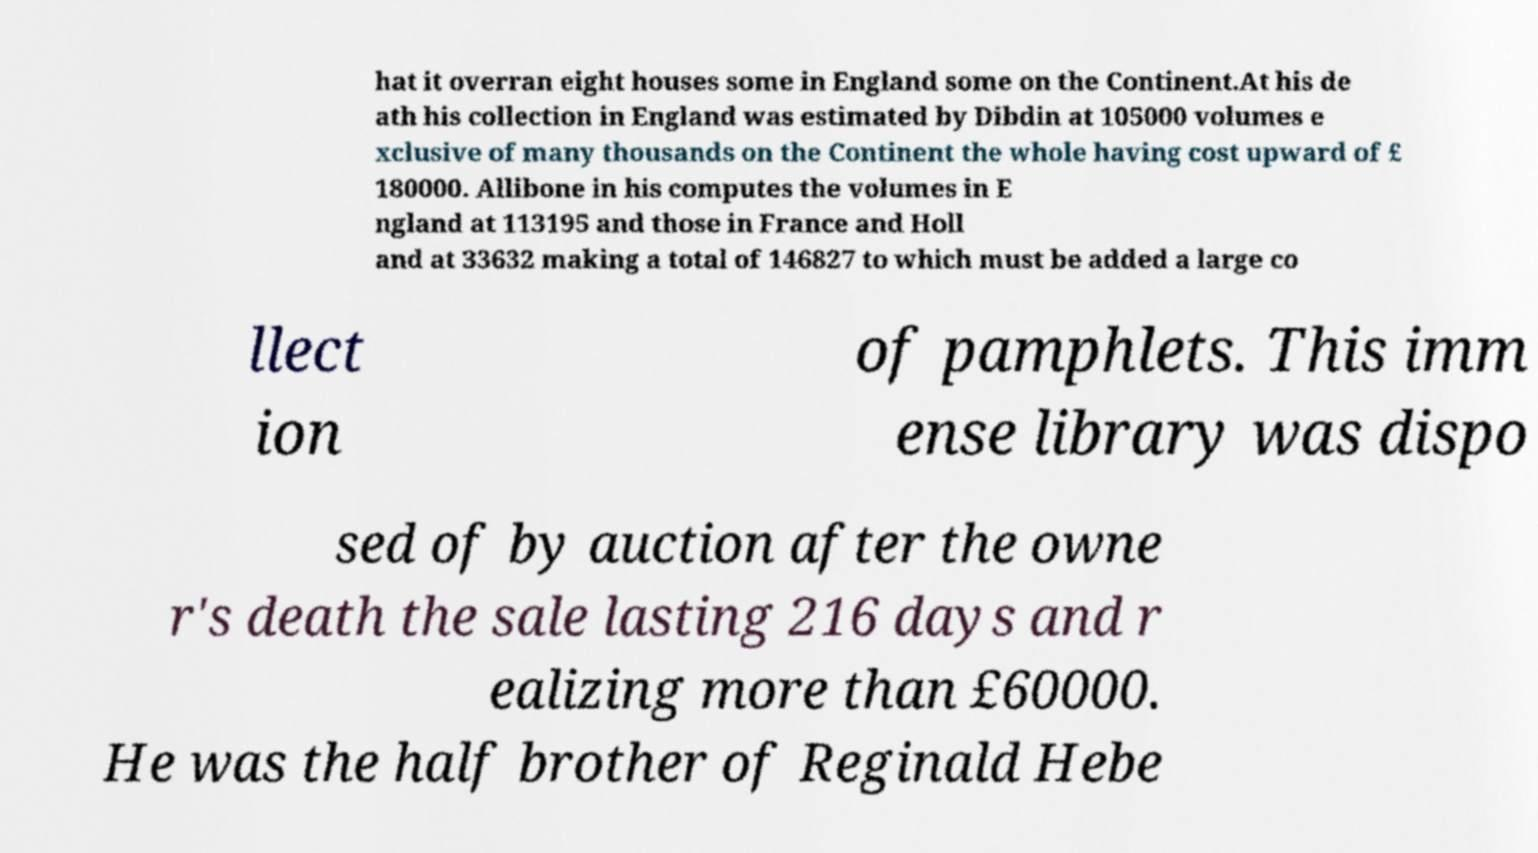Please identify and transcribe the text found in this image. hat it overran eight houses some in England some on the Continent.At his de ath his collection in England was estimated by Dibdin at 105000 volumes e xclusive of many thousands on the Continent the whole having cost upward of £ 180000. Allibone in his computes the volumes in E ngland at 113195 and those in France and Holl and at 33632 making a total of 146827 to which must be added a large co llect ion of pamphlets. This imm ense library was dispo sed of by auction after the owne r's death the sale lasting 216 days and r ealizing more than £60000. He was the half brother of Reginald Hebe 